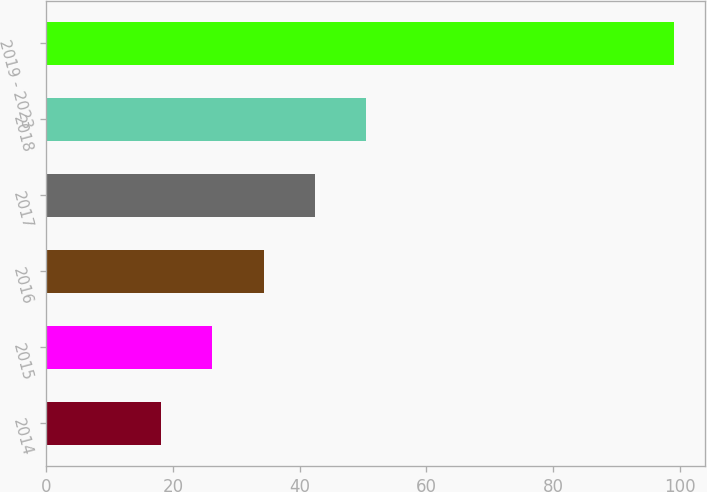<chart> <loc_0><loc_0><loc_500><loc_500><bar_chart><fcel>2014<fcel>2015<fcel>2016<fcel>2017<fcel>2018<fcel>2019 - 2023<nl><fcel>18.1<fcel>26.2<fcel>34.3<fcel>42.4<fcel>50.5<fcel>99.1<nl></chart> 